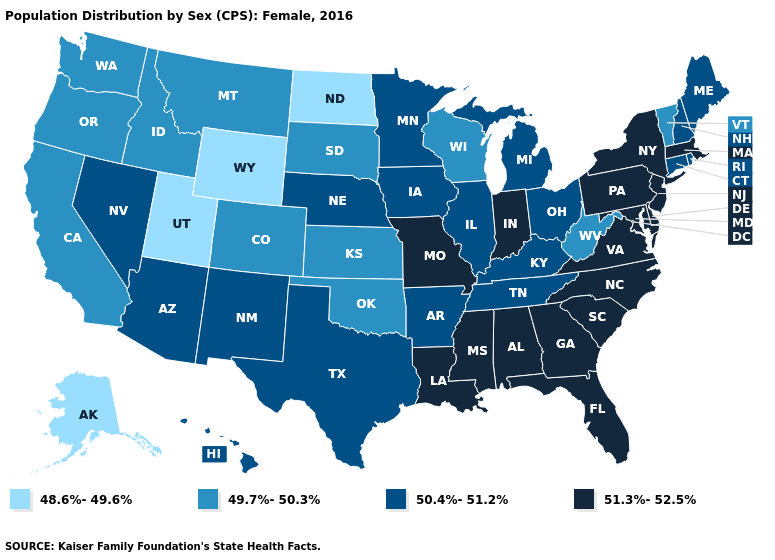Is the legend a continuous bar?
Quick response, please. No. Which states hav the highest value in the South?
Give a very brief answer. Alabama, Delaware, Florida, Georgia, Louisiana, Maryland, Mississippi, North Carolina, South Carolina, Virginia. What is the lowest value in the USA?
Concise answer only. 48.6%-49.6%. Among the states that border Kansas , does Nebraska have the lowest value?
Short answer required. No. Does the map have missing data?
Quick response, please. No. What is the highest value in the USA?
Write a very short answer. 51.3%-52.5%. What is the lowest value in states that border Iowa?
Quick response, please. 49.7%-50.3%. What is the highest value in states that border New Hampshire?
Concise answer only. 51.3%-52.5%. Name the states that have a value in the range 49.7%-50.3%?
Give a very brief answer. California, Colorado, Idaho, Kansas, Montana, Oklahoma, Oregon, South Dakota, Vermont, Washington, West Virginia, Wisconsin. Name the states that have a value in the range 49.7%-50.3%?
Concise answer only. California, Colorado, Idaho, Kansas, Montana, Oklahoma, Oregon, South Dakota, Vermont, Washington, West Virginia, Wisconsin. How many symbols are there in the legend?
Concise answer only. 4. Name the states that have a value in the range 48.6%-49.6%?
Write a very short answer. Alaska, North Dakota, Utah, Wyoming. What is the value of Texas?
Quick response, please. 50.4%-51.2%. What is the lowest value in states that border Alabama?
Short answer required. 50.4%-51.2%. What is the value of Texas?
Write a very short answer. 50.4%-51.2%. 